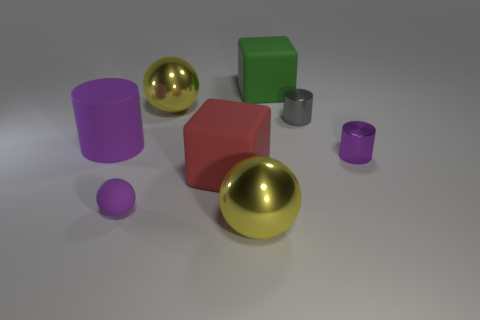There is a large green matte object; is its shape the same as the shiny object that is in front of the tiny purple rubber thing?
Your answer should be very brief. No. What is the material of the green object?
Your answer should be compact. Rubber. What number of shiny things are either tiny gray cylinders or big green blocks?
Your answer should be very brief. 1. Is the number of tiny gray metallic cylinders in front of the gray thing less than the number of cylinders that are in front of the large red matte object?
Your response must be concise. No. There is a big yellow ball behind the shiny sphere that is in front of the tiny gray metal cylinder; are there any purple matte things that are behind it?
Make the answer very short. No. What material is the large cylinder that is the same color as the small rubber sphere?
Give a very brief answer. Rubber. Do the large yellow thing that is in front of the small purple matte thing and the tiny gray metallic object to the right of the red rubber object have the same shape?
Provide a succinct answer. No. What is the material of the red thing that is the same size as the purple rubber cylinder?
Provide a short and direct response. Rubber. Do the big ball behind the large purple thing and the block to the left of the large green thing have the same material?
Ensure brevity in your answer.  No. What shape is the purple metallic thing that is the same size as the purple matte ball?
Keep it short and to the point. Cylinder. 